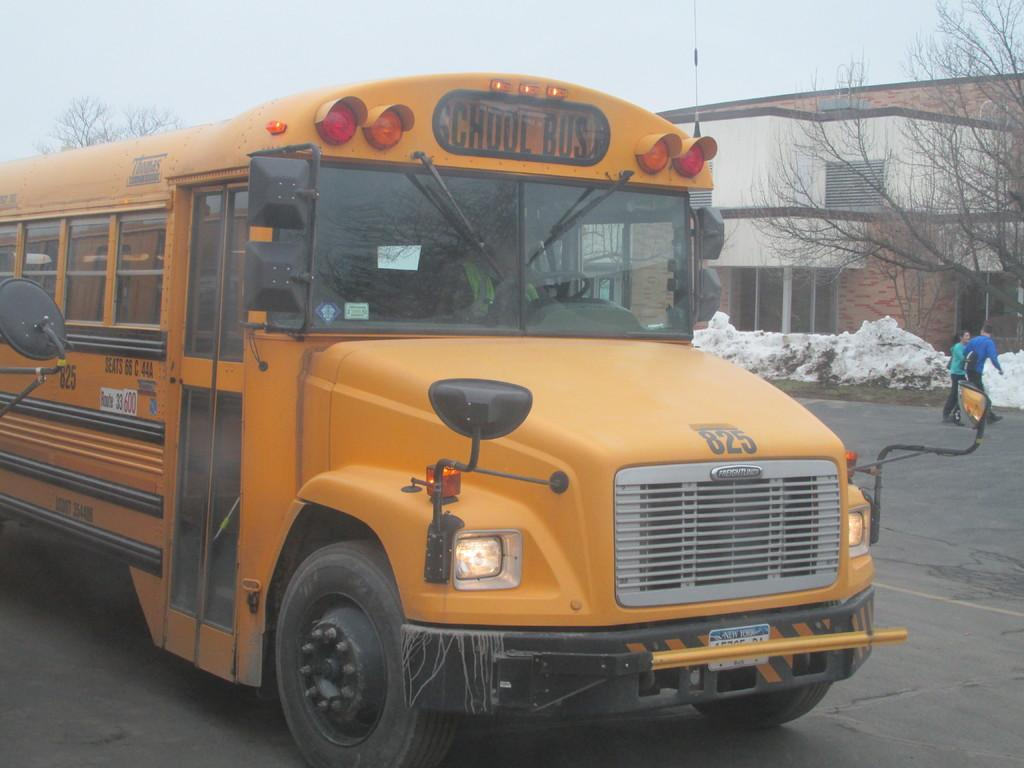What is the main subject of the image? There is a vehicle on the road in the image. What else can be seen near the vehicle? There are people walking beside the road in the image. What type of structures are visible in the image? There are buildings visible in the image. What type of vegetation is present in the image? There are trees present in the image. What type of substance is being harvested from the roof of the building in the image? There is no mention of a substance being harvested from a roof in the image. 